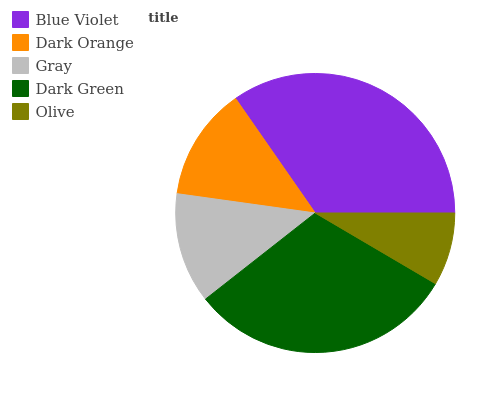Is Olive the minimum?
Answer yes or no. Yes. Is Blue Violet the maximum?
Answer yes or no. Yes. Is Dark Orange the minimum?
Answer yes or no. No. Is Dark Orange the maximum?
Answer yes or no. No. Is Blue Violet greater than Dark Orange?
Answer yes or no. Yes. Is Dark Orange less than Blue Violet?
Answer yes or no. Yes. Is Dark Orange greater than Blue Violet?
Answer yes or no. No. Is Blue Violet less than Dark Orange?
Answer yes or no. No. Is Dark Orange the high median?
Answer yes or no. Yes. Is Dark Orange the low median?
Answer yes or no. Yes. Is Dark Green the high median?
Answer yes or no. No. Is Blue Violet the low median?
Answer yes or no. No. 